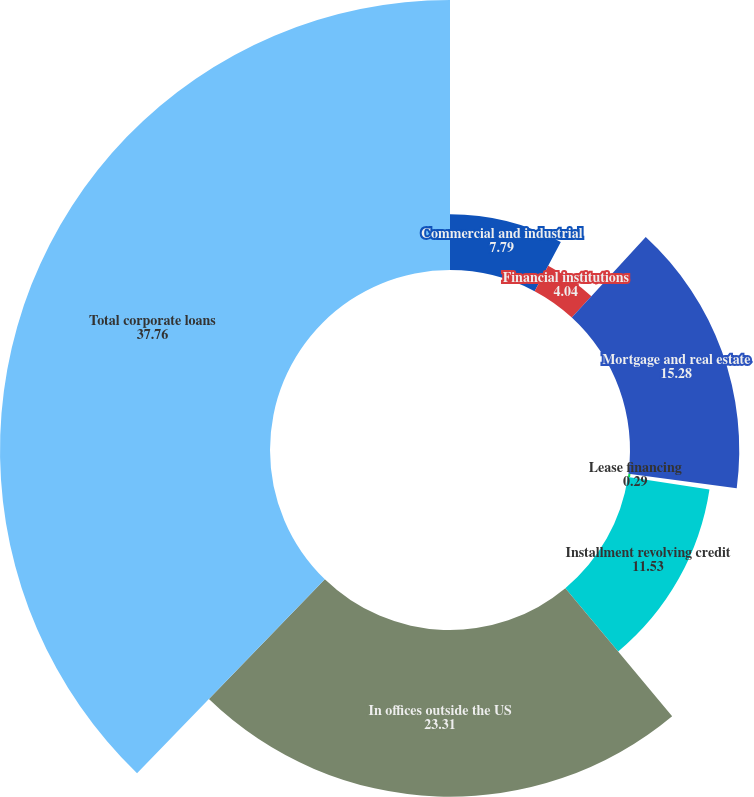Convert chart. <chart><loc_0><loc_0><loc_500><loc_500><pie_chart><fcel>Commercial and industrial<fcel>Financial institutions<fcel>Mortgage and real estate<fcel>Lease financing<fcel>Installment revolving credit<fcel>In offices outside the US<fcel>Total corporate loans<nl><fcel>7.79%<fcel>4.04%<fcel>15.28%<fcel>0.29%<fcel>11.53%<fcel>23.31%<fcel>37.76%<nl></chart> 